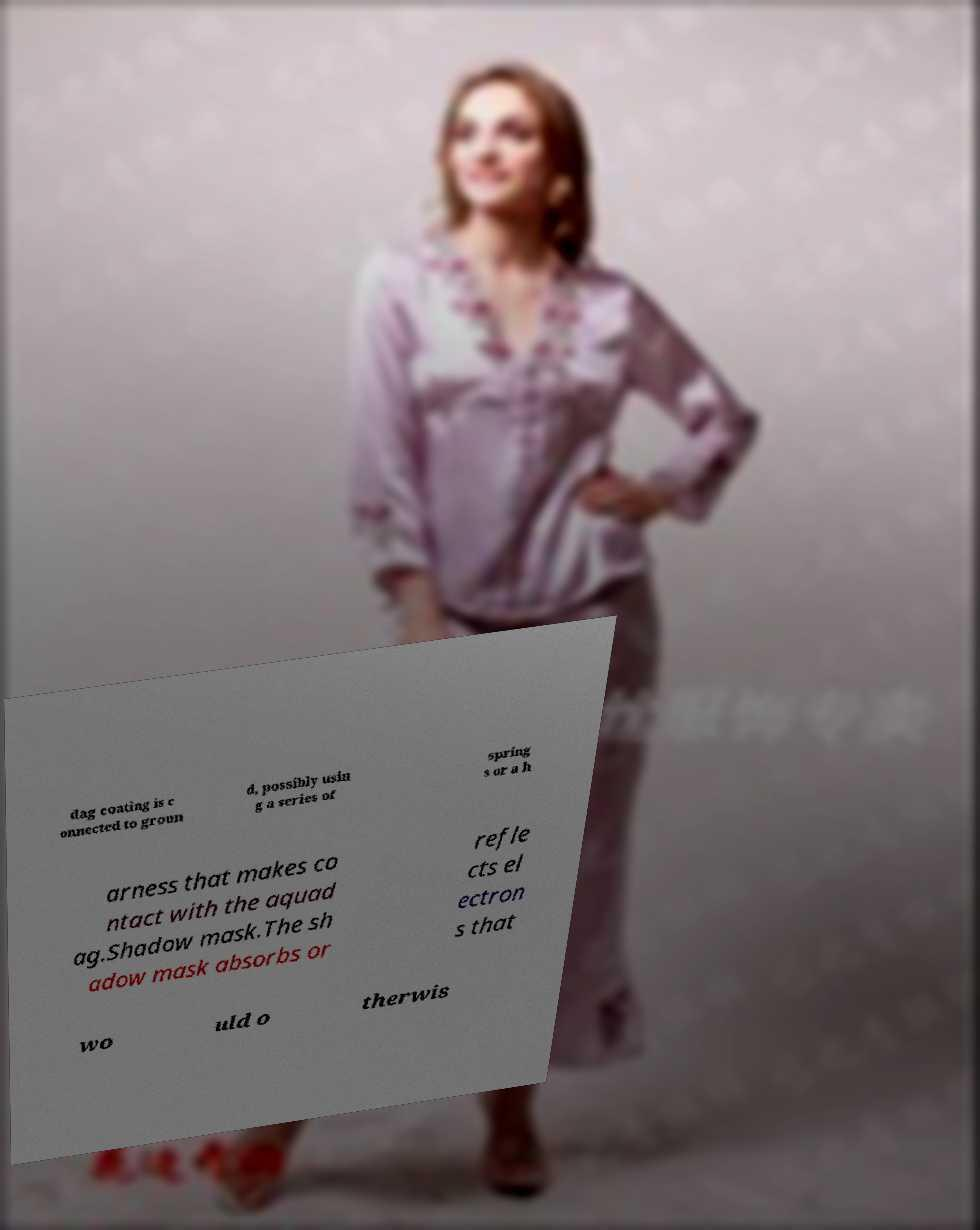There's text embedded in this image that I need extracted. Can you transcribe it verbatim? dag coating is c onnected to groun d, possibly usin g a series of spring s or a h arness that makes co ntact with the aquad ag.Shadow mask.The sh adow mask absorbs or refle cts el ectron s that wo uld o therwis 